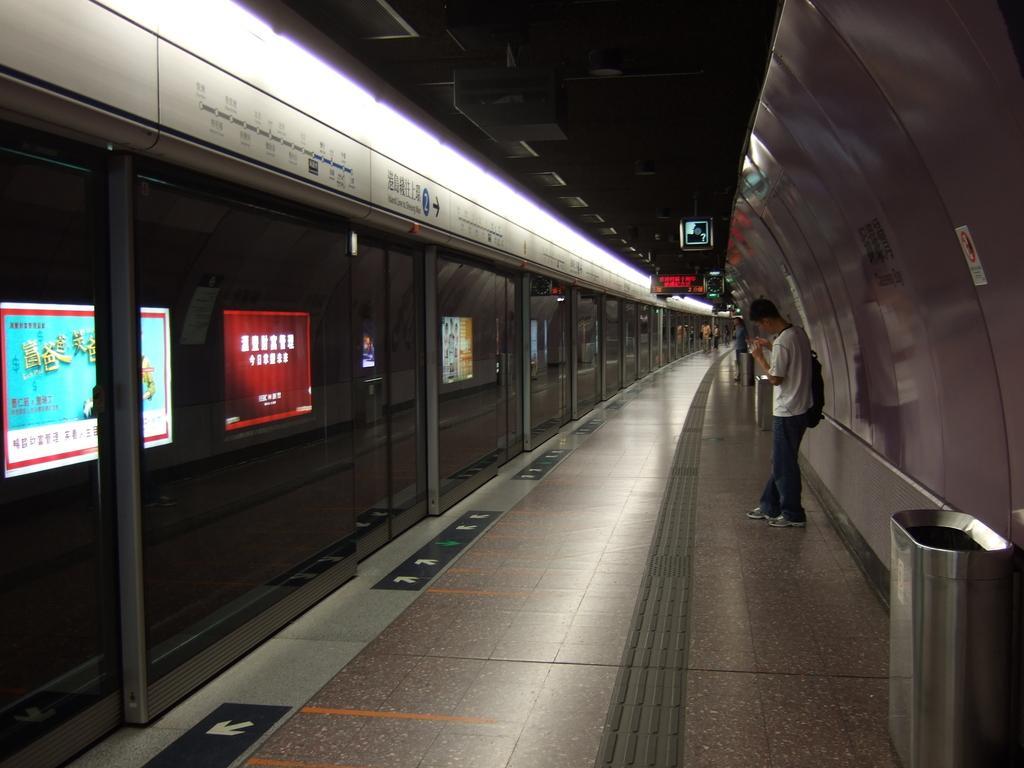Please provide a concise description of this image. In this image we can see a platform, display screen, advertisements, persons on the platform and bins. 